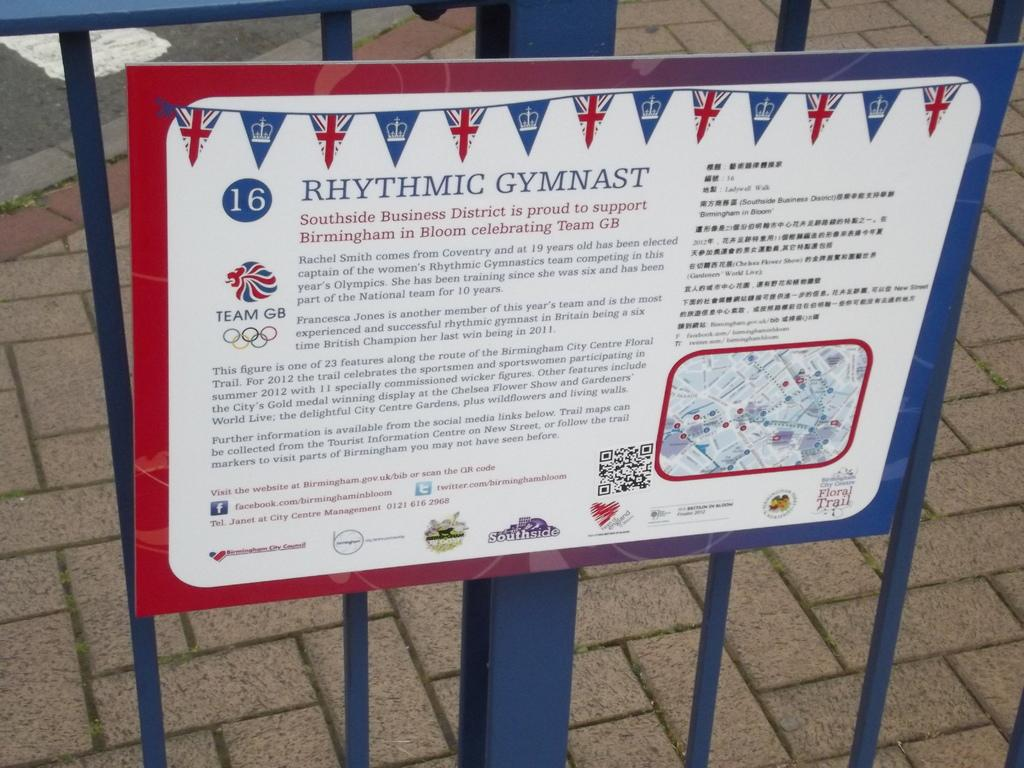Provide a one-sentence caption for the provided image. A metal sign saying Rhythmic Gymnast attached to a blue metal fence. 